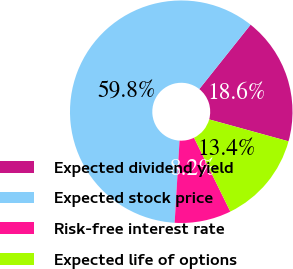Convert chart. <chart><loc_0><loc_0><loc_500><loc_500><pie_chart><fcel>Expected dividend yield<fcel>Expected stock price<fcel>Risk-free interest rate<fcel>Expected life of options<nl><fcel>18.58%<fcel>59.76%<fcel>8.22%<fcel>13.44%<nl></chart> 